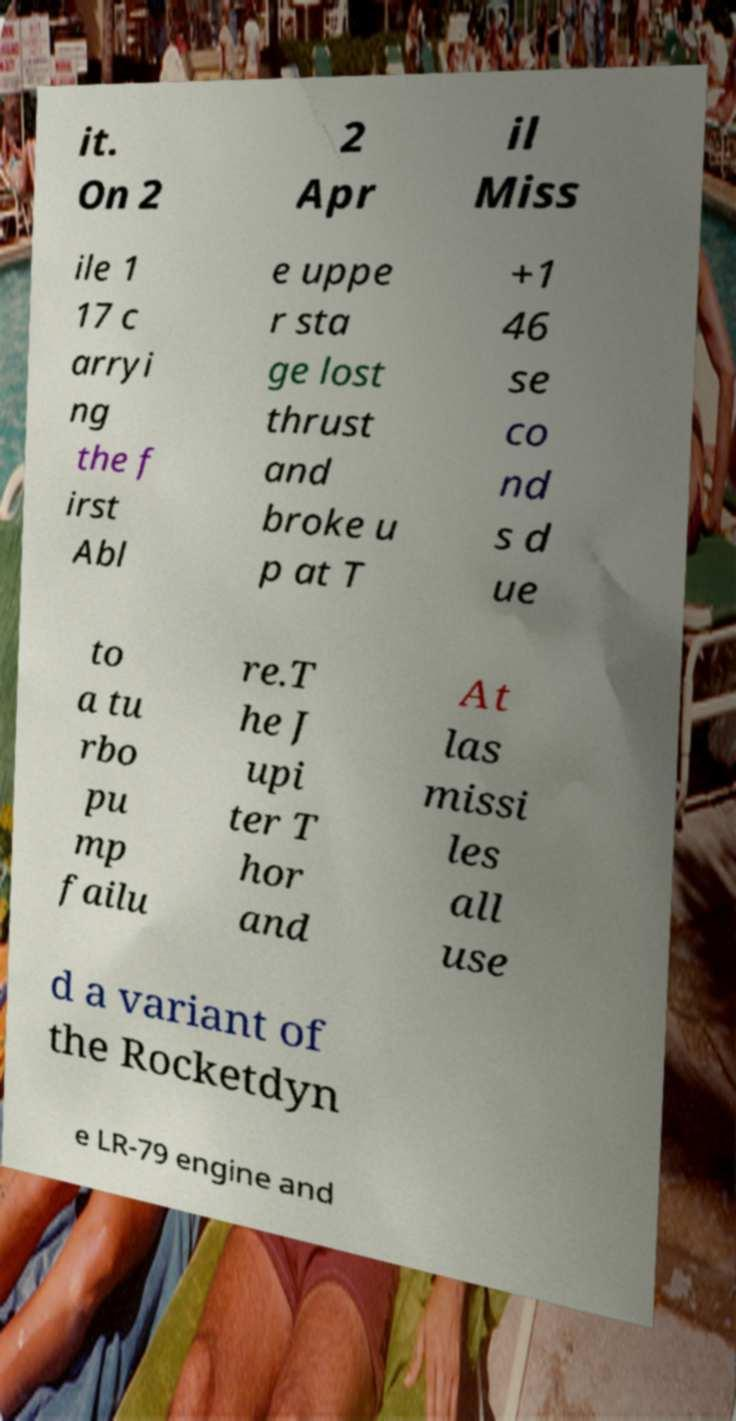Please read and relay the text visible in this image. What does it say? it. On 2 2 Apr il Miss ile 1 17 c arryi ng the f irst Abl e uppe r sta ge lost thrust and broke u p at T +1 46 se co nd s d ue to a tu rbo pu mp failu re.T he J upi ter T hor and At las missi les all use d a variant of the Rocketdyn e LR-79 engine and 